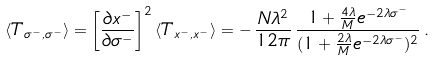Convert formula to latex. <formula><loc_0><loc_0><loc_500><loc_500>\langle T _ { \sigma ^ { - } , \sigma ^ { - } } \rangle = \left [ \frac { \partial x ^ { - } } { \partial \sigma ^ { - } } \right ] ^ { 2 } \langle T _ { x ^ { - } , x ^ { - } } \rangle = - \, \frac { N \lambda ^ { 2 } } { 1 2 \pi } \, \frac { 1 + \frac { 4 \lambda } { M } e ^ { - 2 \lambda \sigma ^ { - } } } { ( 1 + \frac { 2 \lambda } { M } e ^ { - 2 \lambda \sigma ^ { - } } ) ^ { 2 } } \, .</formula> 